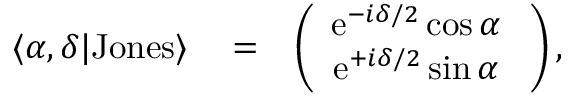Convert formula to latex. <formula><loc_0><loc_0><loc_500><loc_500>\begin{array} { r l r } { \langle \alpha , \delta | J o n e s \rangle } & = } & { \left ( \begin{array} { c } { e ^ { - i \delta / 2 } \cos \alpha \ } \\ { e ^ { + i \delta / 2 } \sin \alpha \ } \end{array} \right ) , } \end{array}</formula> 